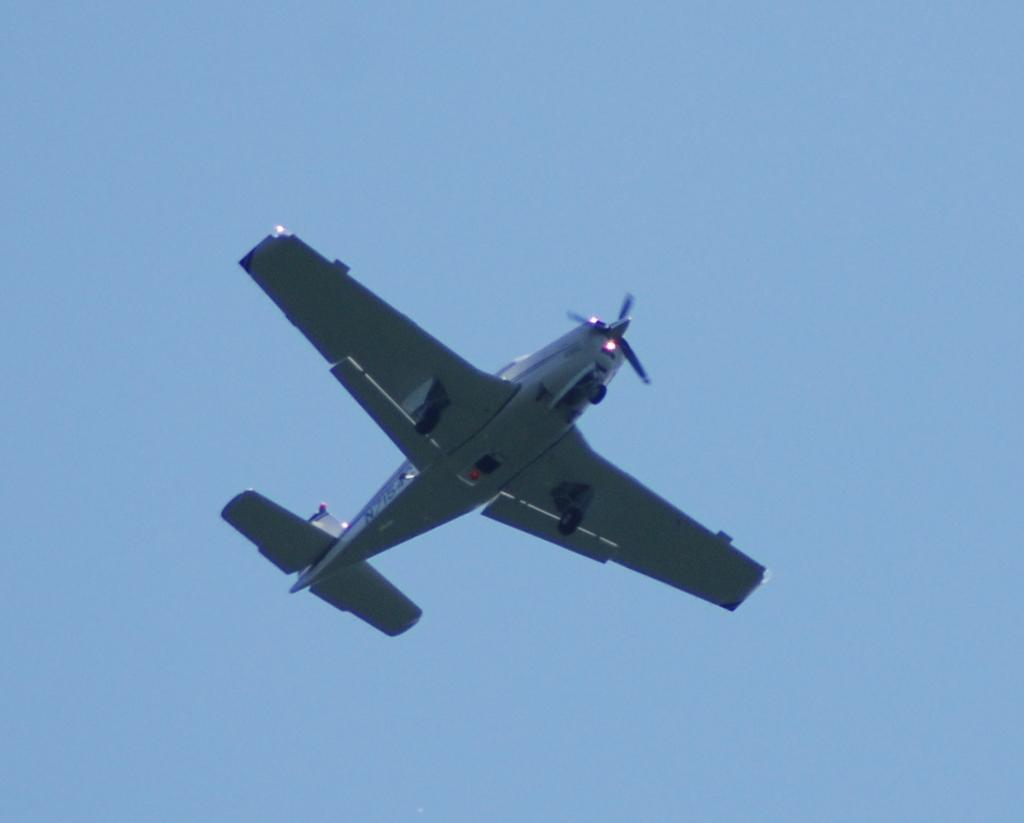What is the main subject of the image? The main subject of the image is an airplane. Where is the airplane located in the image? The airplane is in the center of the image. What can be seen in the background of the image? The sky is visible in the background of the image. What type of wood is used to make the yoke in the image? There is no yoke present in the image, so it is not possible to determine what type of wood might be used. 